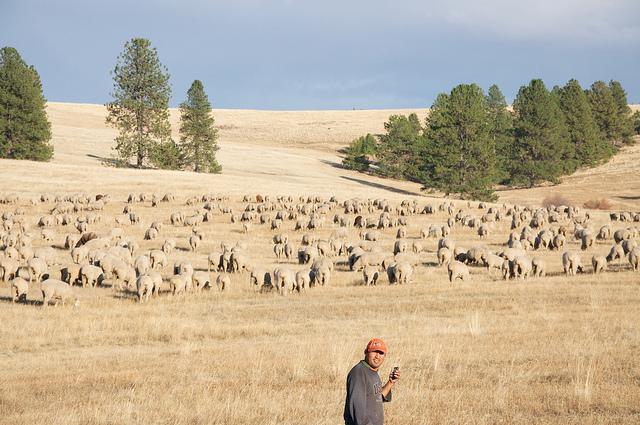How many animals are there?
Concise answer only. 50. Can you see trees?
Keep it brief. Yes. Why species of animal is in the photo?
Keep it brief. Sheep. 